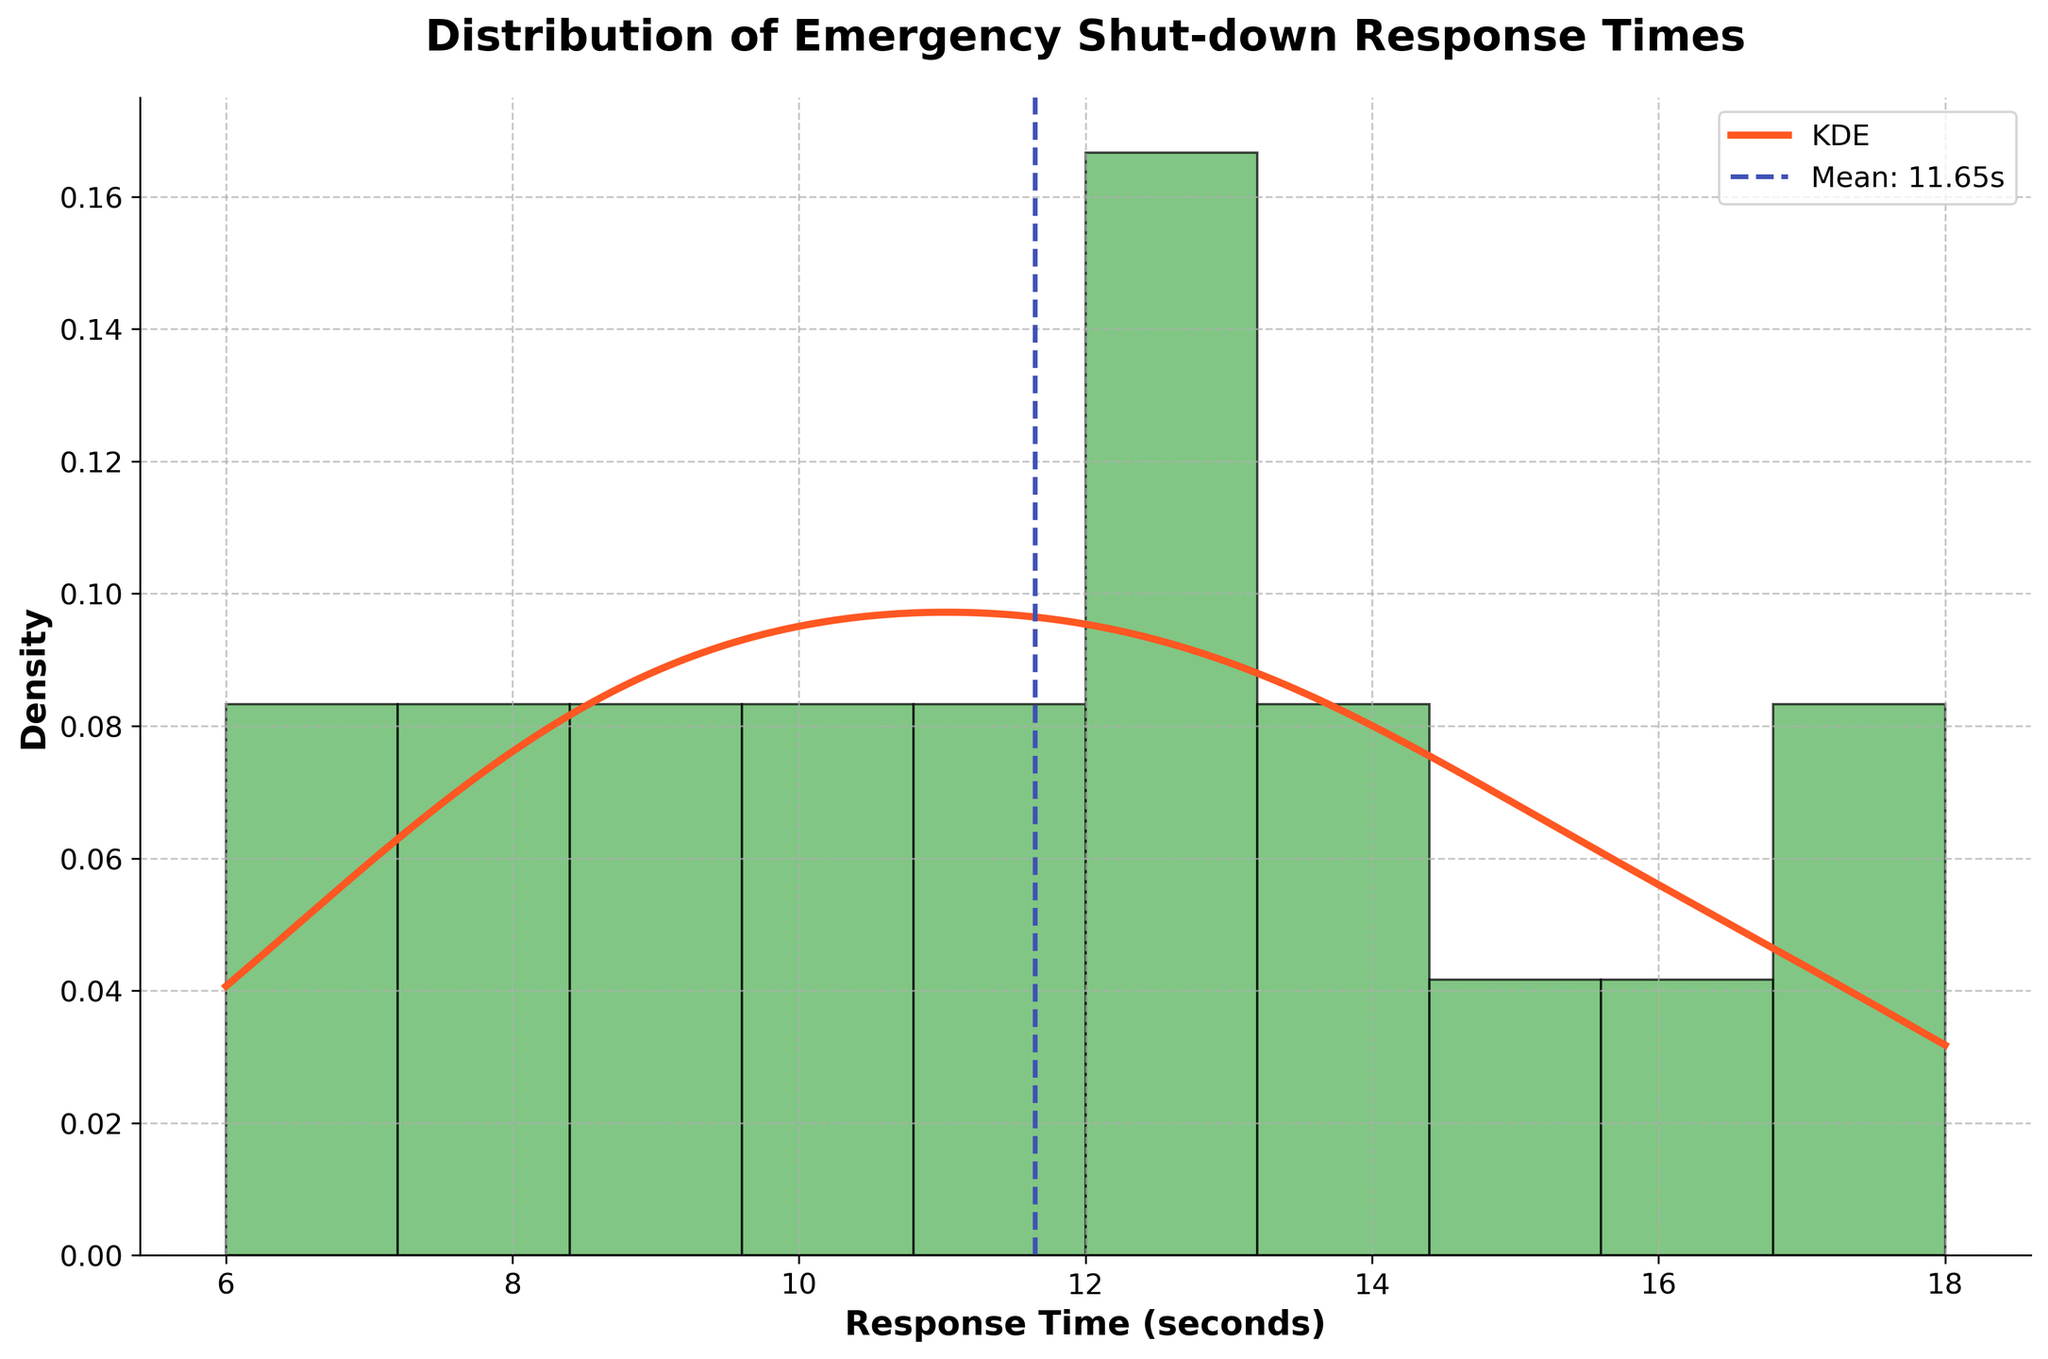What is the title of the figure? The title is displayed at the top of the figure inside the plot area in bold font size 18.
Answer: Distribution of Emergency Shut-down Response Times What is the mean response time for emergency shut-down procedures? The mean response time is indicated by a dashed vertical line labeled "Mean" with its value on the x-axis where the line intersects the axis.
Answer: 11.95 seconds Which response time range has the highest density in the histogram? The tallest bar in the histogram represents the range with the highest density, which can be estimated by looking at both the height of the bars and the density values on the y-axis.
Answer: 10-12 seconds How does the KDE curve help in understanding the distribution compared to the histogram? The KDE (Kernel Density Estimate) curve smooths out the frequencies and provides a continuous estimate of the density function. It allows for a better understanding of the distribution, especially with small sample sizes that might cause the histogram to look jagged or uneven.
Answer: It provides a smoothed representation of the density What is the maximum density value on the y-axis? The peak of the KDE curve represents the maximum density value, which can be read off from the y-axis.
Answer: Approximately 0.13 Are there any response time values that fall outside the main cluster where the mean is located? Observing the spread of the distribution, especially looking at the extremes, can indicate if there are values that fall significantly outside the range where the mean (approximately 12 seconds) is located. This can be deduced by looking at both the histogram and KDE curve.
Answer: Yes, values like 6 seconds and 18 seconds Is there evidence of skewness in the response time distribution? Skewness can be identified by the asymmetry in the shape of the histogram and the KDE curve. If one tail is longer or more pronounced than the other, this suggests skewness.
Answer: Slightly right-skewed How does the density of response times look around the 10-second mark compared to 15-second mark? By comparing the heights of the histogram bars and the KDE curve at these points, it becomes clear if one has a higher density than the other.
Answer: Higher around 10 seconds than 15 seconds Is there a clear mode in the distribution? If so, what is it? The mode can be identified as the peak of the histogram or the highest point on the KDE curve.
Answer: Approximately 10-12 seconds What is the range of response times covered in this dataset? The range can be identified by examining the minimum and maximum values displayed on the x-axis.
Answer: 6-18 seconds 